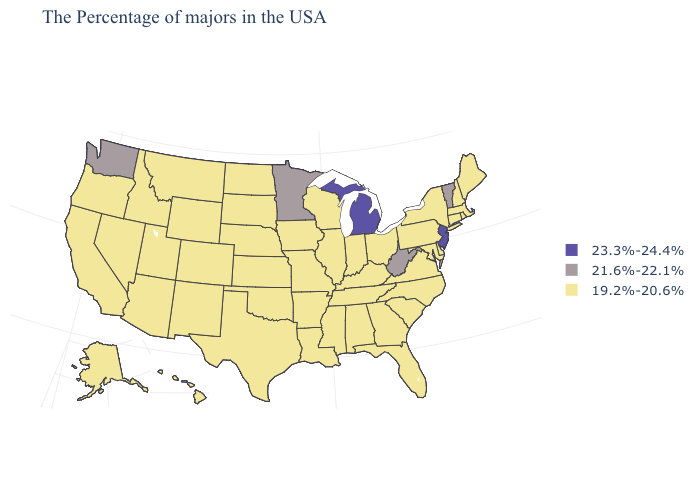What is the value of Oklahoma?
Write a very short answer. 19.2%-20.6%. What is the value of Montana?
Quick response, please. 19.2%-20.6%. What is the lowest value in states that border Indiana?
Keep it brief. 19.2%-20.6%. Does the first symbol in the legend represent the smallest category?
Short answer required. No. What is the lowest value in the MidWest?
Write a very short answer. 19.2%-20.6%. What is the highest value in the West ?
Give a very brief answer. 21.6%-22.1%. What is the highest value in the West ?
Give a very brief answer. 21.6%-22.1%. What is the value of Arizona?
Be succinct. 19.2%-20.6%. Does New Mexico have a higher value than North Dakota?
Answer briefly. No. What is the value of North Dakota?
Be succinct. 19.2%-20.6%. Name the states that have a value in the range 19.2%-20.6%?
Concise answer only. Maine, Massachusetts, Rhode Island, New Hampshire, Connecticut, New York, Delaware, Maryland, Pennsylvania, Virginia, North Carolina, South Carolina, Ohio, Florida, Georgia, Kentucky, Indiana, Alabama, Tennessee, Wisconsin, Illinois, Mississippi, Louisiana, Missouri, Arkansas, Iowa, Kansas, Nebraska, Oklahoma, Texas, South Dakota, North Dakota, Wyoming, Colorado, New Mexico, Utah, Montana, Arizona, Idaho, Nevada, California, Oregon, Alaska, Hawaii. What is the value of Hawaii?
Write a very short answer. 19.2%-20.6%. What is the value of Texas?
Answer briefly. 19.2%-20.6%. What is the highest value in states that border Virginia?
Quick response, please. 21.6%-22.1%. What is the value of Idaho?
Short answer required. 19.2%-20.6%. 